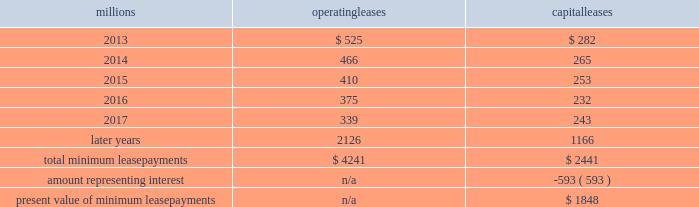Fixed-price purchase options available in the leases could potentially provide benefits to us ; however , these benefits are not expected to be significant .
We maintain and operate the assets based on contractual obligations within the lease arrangements , which set specific guidelines consistent within the railroad industry .
As such , we have no control over activities that could materially impact the fair value of the leased assets .
We do not hold the power to direct the activities of the vies and , therefore , do not control the ongoing activities that have a significant impact on the economic performance of the vies .
Additionally , we do not have the obligation to absorb losses of the vies or the right to receive benefits of the vies that could potentially be significant to the we are not considered to be the primary beneficiary and do not consolidate these vies because our actions and decisions do not have the most significant effect on the vie 2019s performance and our fixed-price purchase price options are not considered to be potentially significant to the vie 2019s .
The future minimum lease payments associated with the vie leases totaled $ 3.6 billion as of december 31 , 2012 .
16 .
Leases we lease certain locomotives , freight cars , and other property .
The consolidated statements of financial position as of december 31 , 2012 and 2011 included $ 2467 million , net of $ 966 million of accumulated depreciation , and $ 2458 million , net of $ 915 million of accumulated depreciation , respectively , for properties held under capital leases .
A charge to income resulting from the depreciation for assets held under capital leases is included within depreciation expense in our consolidated statements of income .
Future minimum lease payments for operating and capital leases with initial or remaining non-cancelable lease terms in excess of one year as of december 31 , 2012 , were as follows : millions operating leases capital leases .
Approximately 94% ( 94 % ) of capital lease payments relate to locomotives .
Rent expense for operating leases with terms exceeding one month was $ 631 million in 2012 , $ 637 million in 2011 , and $ 624 million in 2010 .
When cash rental payments are not made on a straight-line basis , we recognize variable rental expense on a straight-line basis over the lease term .
Contingent rentals and sub-rentals are not significant .
17 .
Commitments and contingencies asserted and unasserted claims 2013 various claims and lawsuits are pending against us and certain of our subsidiaries .
We cannot fully determine the effect of all asserted and unasserted claims on our consolidated results of operations , financial condition , or liquidity ; however , to the extent possible , where asserted and unasserted claims are considered probable and where such claims can be reasonably estimated , we have recorded a liability .
We do not expect that any known lawsuits , claims , environmental costs , commitments , contingent liabilities , or guarantees will have a material adverse effect on our consolidated results of operations , financial condition , or liquidity after taking into account liabilities and insurance recoveries previously recorded for these matters .
Personal injury 2013 the cost of personal injuries to employees and others related to our activities is charged to expense based on estimates of the ultimate cost and number of incidents each year .
We use an actuarial analysis to measure the expense and liability , including unasserted claims .
The federal employers 2019 liability act ( fela ) governs compensation for work-related accidents .
Under fela , damages .
What percentage of total total minimum lease payments are capital leases? 
Computations: (2441 / (4241 + 2441))
Answer: 0.36531. 